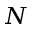<formula> <loc_0><loc_0><loc_500><loc_500>N</formula> 